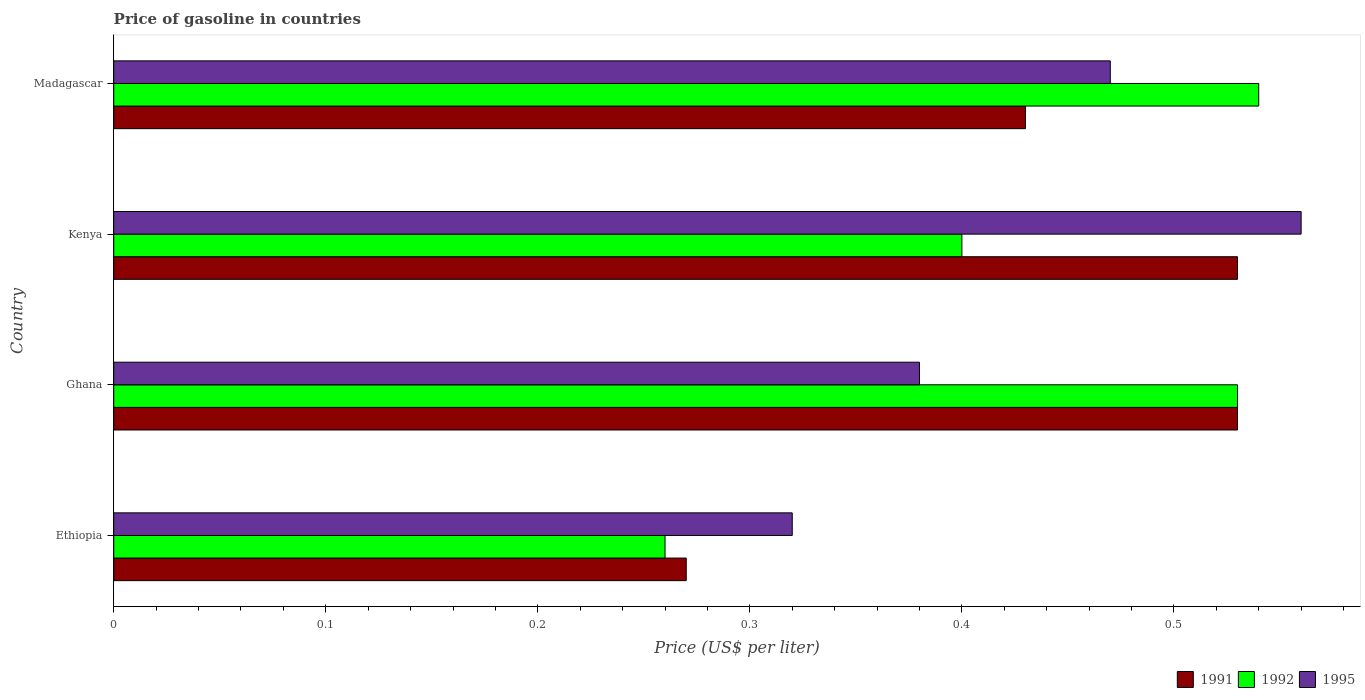Are the number of bars per tick equal to the number of legend labels?
Your answer should be very brief. Yes. Are the number of bars on each tick of the Y-axis equal?
Provide a succinct answer. Yes. How many bars are there on the 1st tick from the bottom?
Offer a terse response. 3. What is the label of the 2nd group of bars from the top?
Ensure brevity in your answer.  Kenya. What is the price of gasoline in 1991 in Ghana?
Keep it short and to the point. 0.53. Across all countries, what is the maximum price of gasoline in 1992?
Keep it short and to the point. 0.54. Across all countries, what is the minimum price of gasoline in 1992?
Your answer should be compact. 0.26. In which country was the price of gasoline in 1995 maximum?
Your response must be concise. Kenya. In which country was the price of gasoline in 1992 minimum?
Your answer should be very brief. Ethiopia. What is the total price of gasoline in 1995 in the graph?
Give a very brief answer. 1.73. What is the difference between the price of gasoline in 1991 in Ghana and that in Kenya?
Keep it short and to the point. 0. What is the difference between the price of gasoline in 1991 in Kenya and the price of gasoline in 1995 in Ethiopia?
Your response must be concise. 0.21. What is the average price of gasoline in 1991 per country?
Keep it short and to the point. 0.44. What is the difference between the price of gasoline in 1991 and price of gasoline in 1992 in Madagascar?
Give a very brief answer. -0.11. In how many countries, is the price of gasoline in 1991 greater than 0.12000000000000001 US$?
Keep it short and to the point. 4. What is the ratio of the price of gasoline in 1991 in Ethiopia to that in Kenya?
Your answer should be compact. 0.51. Is the difference between the price of gasoline in 1991 in Ethiopia and Ghana greater than the difference between the price of gasoline in 1992 in Ethiopia and Ghana?
Provide a short and direct response. Yes. What is the difference between the highest and the second highest price of gasoline in 1992?
Provide a short and direct response. 0.01. What is the difference between the highest and the lowest price of gasoline in 1992?
Your answer should be very brief. 0.28. In how many countries, is the price of gasoline in 1992 greater than the average price of gasoline in 1992 taken over all countries?
Provide a short and direct response. 2. Is the sum of the price of gasoline in 1992 in Ethiopia and Madagascar greater than the maximum price of gasoline in 1995 across all countries?
Provide a succinct answer. Yes. How many bars are there?
Offer a terse response. 12. How many countries are there in the graph?
Keep it short and to the point. 4. What is the difference between two consecutive major ticks on the X-axis?
Provide a short and direct response. 0.1. Are the values on the major ticks of X-axis written in scientific E-notation?
Offer a very short reply. No. Does the graph contain any zero values?
Offer a very short reply. No. Does the graph contain grids?
Give a very brief answer. No. Where does the legend appear in the graph?
Provide a succinct answer. Bottom right. What is the title of the graph?
Offer a terse response. Price of gasoline in countries. Does "2004" appear as one of the legend labels in the graph?
Provide a succinct answer. No. What is the label or title of the X-axis?
Provide a short and direct response. Price (US$ per liter). What is the label or title of the Y-axis?
Keep it short and to the point. Country. What is the Price (US$ per liter) in 1991 in Ethiopia?
Offer a terse response. 0.27. What is the Price (US$ per liter) in 1992 in Ethiopia?
Your answer should be compact. 0.26. What is the Price (US$ per liter) in 1995 in Ethiopia?
Make the answer very short. 0.32. What is the Price (US$ per liter) in 1991 in Ghana?
Offer a terse response. 0.53. What is the Price (US$ per liter) of 1992 in Ghana?
Your response must be concise. 0.53. What is the Price (US$ per liter) of 1995 in Ghana?
Make the answer very short. 0.38. What is the Price (US$ per liter) in 1991 in Kenya?
Your answer should be compact. 0.53. What is the Price (US$ per liter) in 1992 in Kenya?
Offer a very short reply. 0.4. What is the Price (US$ per liter) of 1995 in Kenya?
Offer a very short reply. 0.56. What is the Price (US$ per liter) of 1991 in Madagascar?
Keep it short and to the point. 0.43. What is the Price (US$ per liter) of 1992 in Madagascar?
Provide a short and direct response. 0.54. What is the Price (US$ per liter) in 1995 in Madagascar?
Make the answer very short. 0.47. Across all countries, what is the maximum Price (US$ per liter) in 1991?
Provide a succinct answer. 0.53. Across all countries, what is the maximum Price (US$ per liter) of 1992?
Offer a terse response. 0.54. Across all countries, what is the maximum Price (US$ per liter) of 1995?
Make the answer very short. 0.56. Across all countries, what is the minimum Price (US$ per liter) of 1991?
Provide a short and direct response. 0.27. Across all countries, what is the minimum Price (US$ per liter) in 1992?
Your answer should be compact. 0.26. Across all countries, what is the minimum Price (US$ per liter) in 1995?
Offer a terse response. 0.32. What is the total Price (US$ per liter) of 1991 in the graph?
Offer a terse response. 1.76. What is the total Price (US$ per liter) of 1992 in the graph?
Offer a terse response. 1.73. What is the total Price (US$ per liter) in 1995 in the graph?
Offer a terse response. 1.73. What is the difference between the Price (US$ per liter) of 1991 in Ethiopia and that in Ghana?
Keep it short and to the point. -0.26. What is the difference between the Price (US$ per liter) of 1992 in Ethiopia and that in Ghana?
Make the answer very short. -0.27. What is the difference between the Price (US$ per liter) in 1995 in Ethiopia and that in Ghana?
Ensure brevity in your answer.  -0.06. What is the difference between the Price (US$ per liter) in 1991 in Ethiopia and that in Kenya?
Ensure brevity in your answer.  -0.26. What is the difference between the Price (US$ per liter) in 1992 in Ethiopia and that in Kenya?
Ensure brevity in your answer.  -0.14. What is the difference between the Price (US$ per liter) of 1995 in Ethiopia and that in Kenya?
Provide a succinct answer. -0.24. What is the difference between the Price (US$ per liter) of 1991 in Ethiopia and that in Madagascar?
Your answer should be very brief. -0.16. What is the difference between the Price (US$ per liter) of 1992 in Ethiopia and that in Madagascar?
Make the answer very short. -0.28. What is the difference between the Price (US$ per liter) of 1992 in Ghana and that in Kenya?
Make the answer very short. 0.13. What is the difference between the Price (US$ per liter) in 1995 in Ghana and that in Kenya?
Your response must be concise. -0.18. What is the difference between the Price (US$ per liter) in 1991 in Ghana and that in Madagascar?
Make the answer very short. 0.1. What is the difference between the Price (US$ per liter) of 1992 in Ghana and that in Madagascar?
Your answer should be compact. -0.01. What is the difference between the Price (US$ per liter) of 1995 in Ghana and that in Madagascar?
Offer a very short reply. -0.09. What is the difference between the Price (US$ per liter) of 1992 in Kenya and that in Madagascar?
Provide a short and direct response. -0.14. What is the difference between the Price (US$ per liter) in 1995 in Kenya and that in Madagascar?
Provide a succinct answer. 0.09. What is the difference between the Price (US$ per liter) in 1991 in Ethiopia and the Price (US$ per liter) in 1992 in Ghana?
Keep it short and to the point. -0.26. What is the difference between the Price (US$ per liter) in 1991 in Ethiopia and the Price (US$ per liter) in 1995 in Ghana?
Give a very brief answer. -0.11. What is the difference between the Price (US$ per liter) in 1992 in Ethiopia and the Price (US$ per liter) in 1995 in Ghana?
Ensure brevity in your answer.  -0.12. What is the difference between the Price (US$ per liter) in 1991 in Ethiopia and the Price (US$ per liter) in 1992 in Kenya?
Offer a terse response. -0.13. What is the difference between the Price (US$ per liter) in 1991 in Ethiopia and the Price (US$ per liter) in 1995 in Kenya?
Keep it short and to the point. -0.29. What is the difference between the Price (US$ per liter) in 1991 in Ethiopia and the Price (US$ per liter) in 1992 in Madagascar?
Your answer should be compact. -0.27. What is the difference between the Price (US$ per liter) in 1992 in Ethiopia and the Price (US$ per liter) in 1995 in Madagascar?
Offer a very short reply. -0.21. What is the difference between the Price (US$ per liter) of 1991 in Ghana and the Price (US$ per liter) of 1992 in Kenya?
Your answer should be compact. 0.13. What is the difference between the Price (US$ per liter) of 1991 in Ghana and the Price (US$ per liter) of 1995 in Kenya?
Make the answer very short. -0.03. What is the difference between the Price (US$ per liter) of 1992 in Ghana and the Price (US$ per liter) of 1995 in Kenya?
Ensure brevity in your answer.  -0.03. What is the difference between the Price (US$ per liter) in 1991 in Ghana and the Price (US$ per liter) in 1992 in Madagascar?
Your answer should be compact. -0.01. What is the difference between the Price (US$ per liter) in 1991 in Ghana and the Price (US$ per liter) in 1995 in Madagascar?
Give a very brief answer. 0.06. What is the difference between the Price (US$ per liter) in 1991 in Kenya and the Price (US$ per liter) in 1992 in Madagascar?
Your response must be concise. -0.01. What is the difference between the Price (US$ per liter) of 1991 in Kenya and the Price (US$ per liter) of 1995 in Madagascar?
Provide a succinct answer. 0.06. What is the difference between the Price (US$ per liter) in 1992 in Kenya and the Price (US$ per liter) in 1995 in Madagascar?
Your response must be concise. -0.07. What is the average Price (US$ per liter) in 1991 per country?
Keep it short and to the point. 0.44. What is the average Price (US$ per liter) of 1992 per country?
Give a very brief answer. 0.43. What is the average Price (US$ per liter) of 1995 per country?
Provide a short and direct response. 0.43. What is the difference between the Price (US$ per liter) of 1991 and Price (US$ per liter) of 1992 in Ethiopia?
Your answer should be compact. 0.01. What is the difference between the Price (US$ per liter) in 1992 and Price (US$ per liter) in 1995 in Ethiopia?
Your answer should be very brief. -0.06. What is the difference between the Price (US$ per liter) in 1991 and Price (US$ per liter) in 1992 in Kenya?
Give a very brief answer. 0.13. What is the difference between the Price (US$ per liter) of 1991 and Price (US$ per liter) of 1995 in Kenya?
Ensure brevity in your answer.  -0.03. What is the difference between the Price (US$ per liter) of 1992 and Price (US$ per liter) of 1995 in Kenya?
Offer a terse response. -0.16. What is the difference between the Price (US$ per liter) of 1991 and Price (US$ per liter) of 1992 in Madagascar?
Your response must be concise. -0.11. What is the difference between the Price (US$ per liter) in 1991 and Price (US$ per liter) in 1995 in Madagascar?
Ensure brevity in your answer.  -0.04. What is the difference between the Price (US$ per liter) of 1992 and Price (US$ per liter) of 1995 in Madagascar?
Provide a short and direct response. 0.07. What is the ratio of the Price (US$ per liter) of 1991 in Ethiopia to that in Ghana?
Make the answer very short. 0.51. What is the ratio of the Price (US$ per liter) of 1992 in Ethiopia to that in Ghana?
Give a very brief answer. 0.49. What is the ratio of the Price (US$ per liter) of 1995 in Ethiopia to that in Ghana?
Keep it short and to the point. 0.84. What is the ratio of the Price (US$ per liter) in 1991 in Ethiopia to that in Kenya?
Your response must be concise. 0.51. What is the ratio of the Price (US$ per liter) of 1992 in Ethiopia to that in Kenya?
Provide a succinct answer. 0.65. What is the ratio of the Price (US$ per liter) in 1995 in Ethiopia to that in Kenya?
Provide a succinct answer. 0.57. What is the ratio of the Price (US$ per liter) of 1991 in Ethiopia to that in Madagascar?
Provide a short and direct response. 0.63. What is the ratio of the Price (US$ per liter) in 1992 in Ethiopia to that in Madagascar?
Offer a very short reply. 0.48. What is the ratio of the Price (US$ per liter) of 1995 in Ethiopia to that in Madagascar?
Keep it short and to the point. 0.68. What is the ratio of the Price (US$ per liter) of 1992 in Ghana to that in Kenya?
Keep it short and to the point. 1.32. What is the ratio of the Price (US$ per liter) in 1995 in Ghana to that in Kenya?
Offer a terse response. 0.68. What is the ratio of the Price (US$ per liter) of 1991 in Ghana to that in Madagascar?
Offer a very short reply. 1.23. What is the ratio of the Price (US$ per liter) in 1992 in Ghana to that in Madagascar?
Give a very brief answer. 0.98. What is the ratio of the Price (US$ per liter) of 1995 in Ghana to that in Madagascar?
Provide a short and direct response. 0.81. What is the ratio of the Price (US$ per liter) in 1991 in Kenya to that in Madagascar?
Give a very brief answer. 1.23. What is the ratio of the Price (US$ per liter) in 1992 in Kenya to that in Madagascar?
Offer a very short reply. 0.74. What is the ratio of the Price (US$ per liter) in 1995 in Kenya to that in Madagascar?
Offer a terse response. 1.19. What is the difference between the highest and the second highest Price (US$ per liter) in 1991?
Ensure brevity in your answer.  0. What is the difference between the highest and the second highest Price (US$ per liter) in 1995?
Give a very brief answer. 0.09. What is the difference between the highest and the lowest Price (US$ per liter) in 1991?
Offer a very short reply. 0.26. What is the difference between the highest and the lowest Price (US$ per liter) in 1992?
Your response must be concise. 0.28. What is the difference between the highest and the lowest Price (US$ per liter) in 1995?
Offer a terse response. 0.24. 